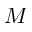<formula> <loc_0><loc_0><loc_500><loc_500>M</formula> 